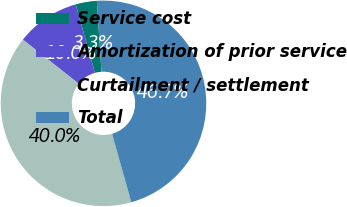Convert chart. <chart><loc_0><loc_0><loc_500><loc_500><pie_chart><fcel>Service cost<fcel>Amortization of prior service<fcel>Curtailment / settlement<fcel>Total<nl><fcel>3.33%<fcel>10.0%<fcel>40.0%<fcel>46.67%<nl></chart> 